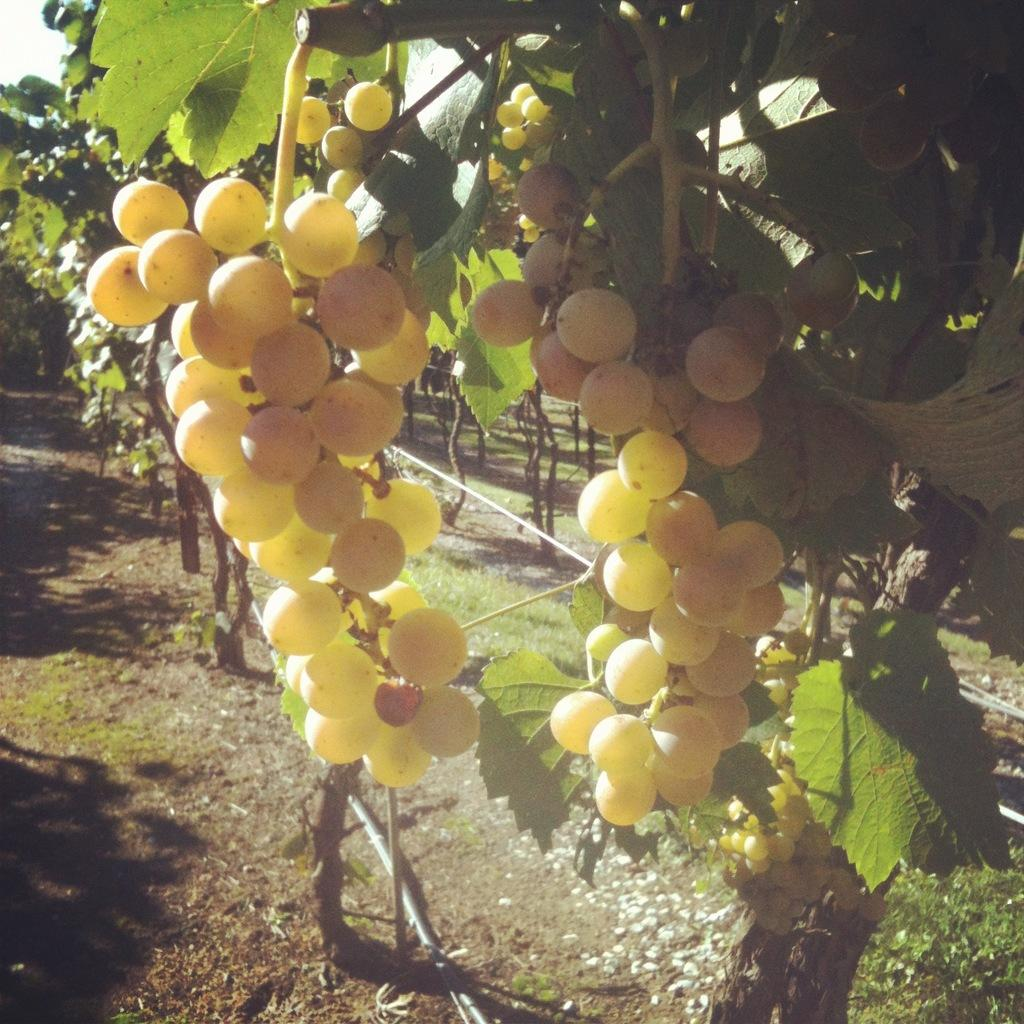What type of landscape is depicted in the image? There is a vineyard in the image. What other structures can be seen in the image? There are pipelines in the image. What is visible in the sky in the image? The sky is visible in the image. What type of town is being attacked by a giant in the image? There is no town or giant present in the image; it features a vineyard and pipelines. 